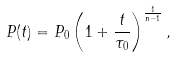<formula> <loc_0><loc_0><loc_500><loc_500>P ( t ) = P _ { 0 } \left ( 1 + \frac { t } { \tau _ { 0 } } \right ) ^ { \frac { 1 } { n - 1 } } ,</formula> 